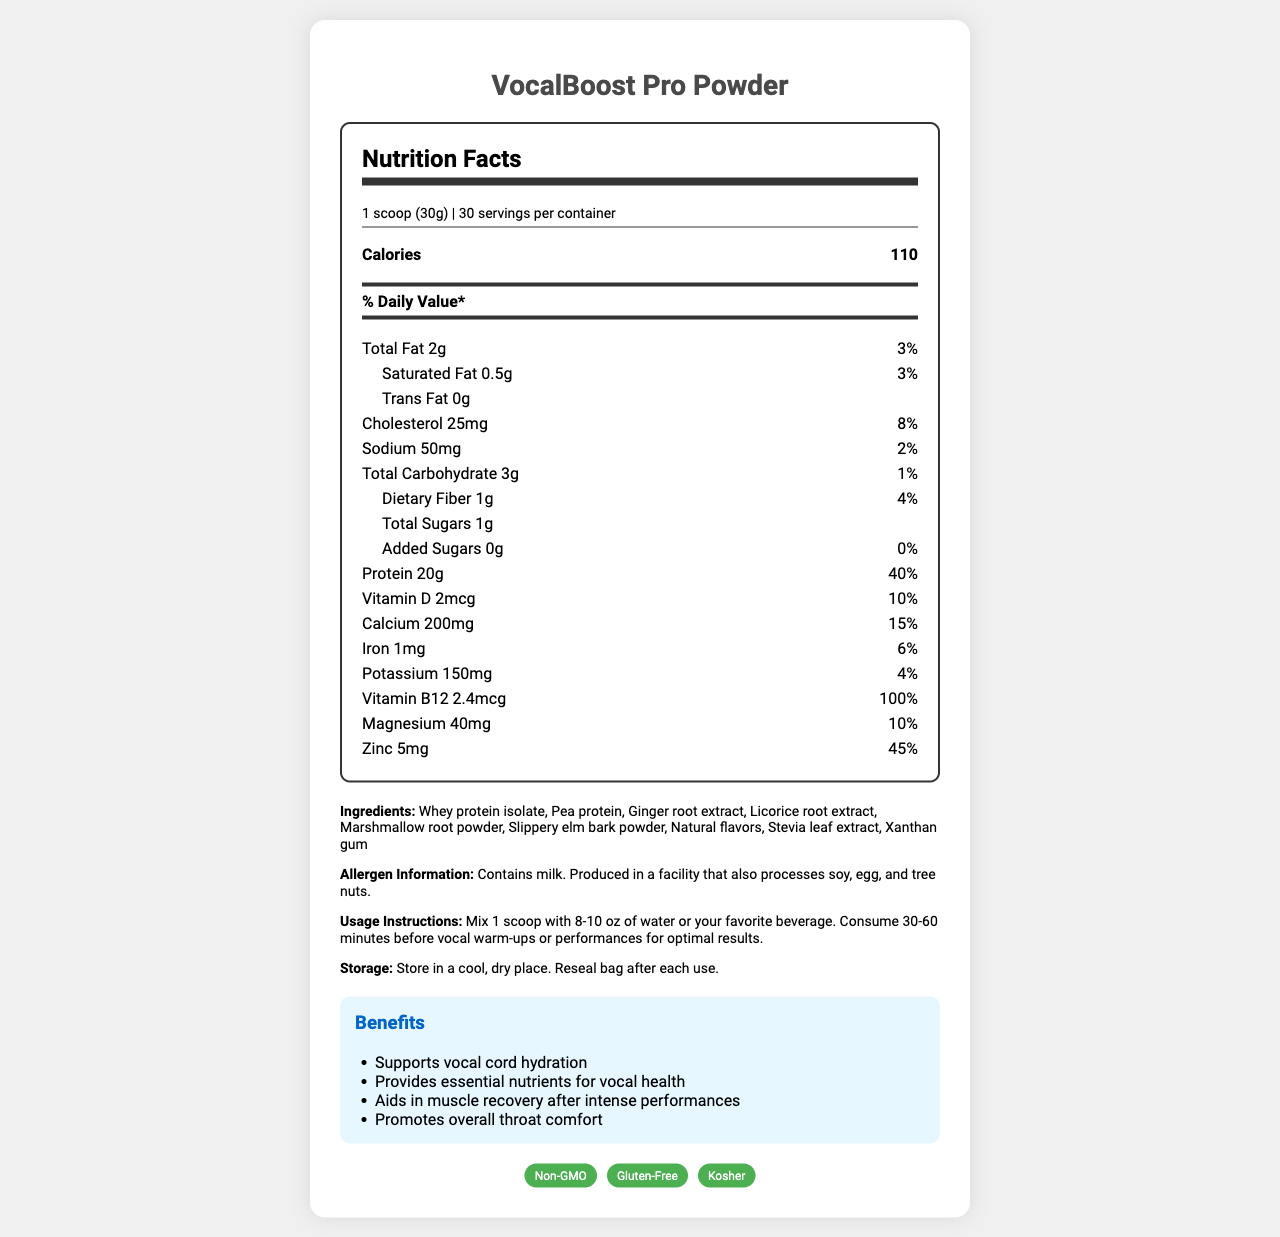what is the serving size for VocalBoost Pro Powder? The serving size is mentioned at the beginning of the Nutrition Facts section.
Answer: 1 scoop (30g) how many calories are in one serving of VocalBoost Pro Powder? This nutritional information is specifically listed under the bold section for calories.
Answer: 110 what percent of the daily value does 20g of protein provide? The daily value percentage for protein is indicated next to the amount of 20g of protein.
Answer: 40% how much iron is in one serving, and what percentage of the daily value does this represent? The document lists the amount of iron and its corresponding daily value percentage under the individual nutrient section.
Answer: 1mg, 6% which ingredient is listed first in the ingredients list? The ingredients list starts with "Whey protein isolate" as the first item.
Answer: Whey protein isolate what type of fat is completely absent from VocalBoost Pro Powder? The document states "Trans fat 0g," indicating it is absent from the product.
Answer: Trans fat how much dietary fiber is there per serving? A. 0.5g B. 1g C. 2g The amount of dietary fiber per serving, 1g, is listed under the nutrient details.
Answer: B what is the percentage daily value of vitamin D in this product? A. 5% B. 10% C. 15% D. 20% The percentage daily value of vitamin D is mentioned as 10%.
Answer: B does VocalBoost Pro Powder contain added sugars? The document indicates "Added Sugars 0g" showing there are no added sugars.
Answer: No is this product gluten-free? The document lists "Gluten-Free" as one of the certifications.
Answer: Yes summarize the entire document or the main idea of the document. This summary describes the key points of the document, including the product's purpose, nutritional content, ingredients, and certifications.
Answer: VocalBoost Pro Powder is a protein supplement designed to support vocal health and hydration, providing essential nutrients like protein, vitamins, and minerals. It contains natural ingredients and is certified non-GMO, gluten-free, and kosher. The product is meant to be consumed before vocal warm-ups for optimal results. what is the manufacturing date for this product? The document does not provide any details about the manufacturing date of the product.
Answer: Not enough information 